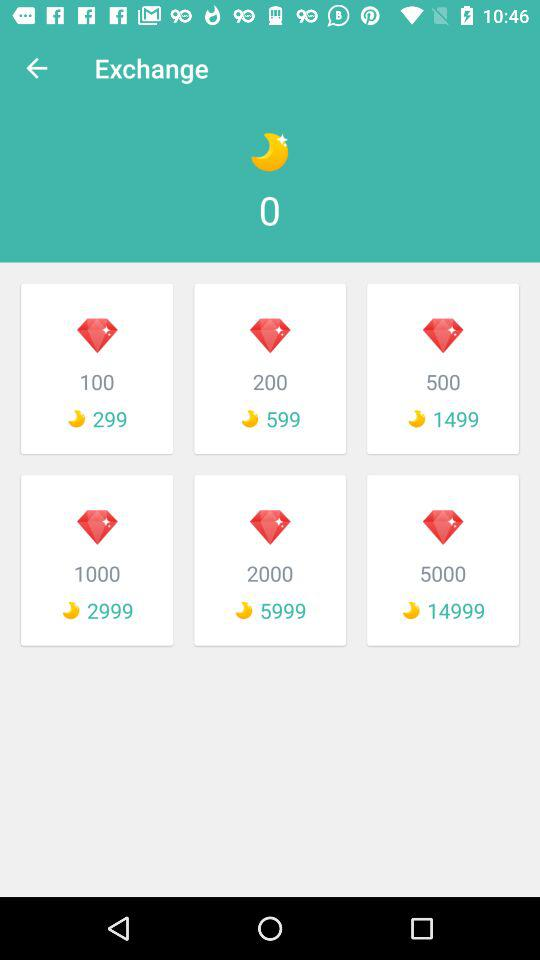What is the exchange value of 100 diamonds? The exchange value of 100 diamonds is 299 moons. 